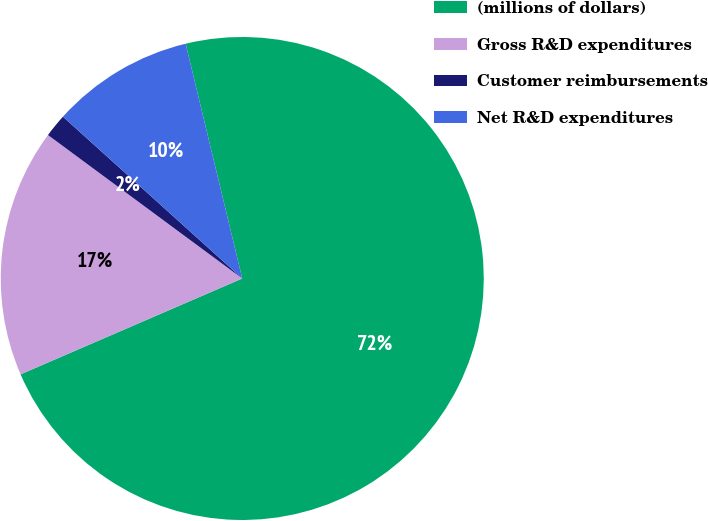Convert chart to OTSL. <chart><loc_0><loc_0><loc_500><loc_500><pie_chart><fcel>(millions of dollars)<fcel>Gross R&D expenditures<fcel>Customer reimbursements<fcel>Net R&D expenditures<nl><fcel>72.27%<fcel>16.62%<fcel>1.56%<fcel>9.55%<nl></chart> 